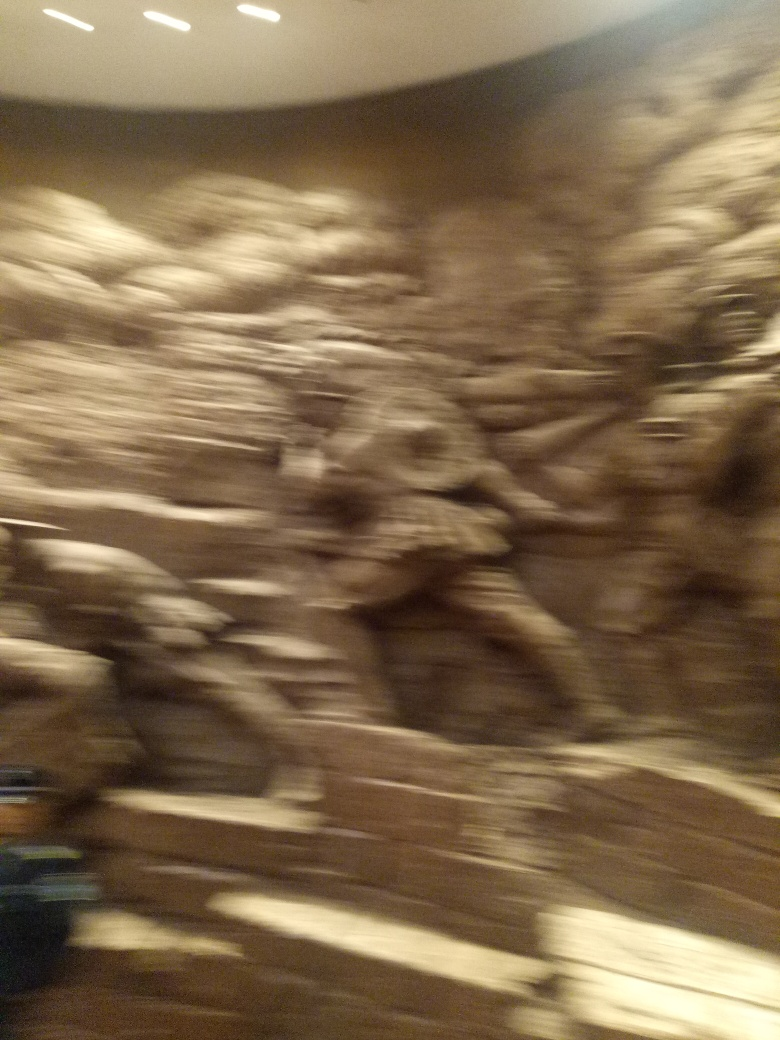Considering the blurriness of this image, what are some creative ways it could be used artistically? The blurry aesthetic of this image can be artistically leveraged to evoke feelings of mystery, memory, or movement. It could serve as a background for a graphic design project, convey a dreamlike state in a multimedia artwork, or even be layered with text and other images to create a mixed media collage. Artists can exploit its lack of clarity to leave interpretation open to the viewer's imagination. 